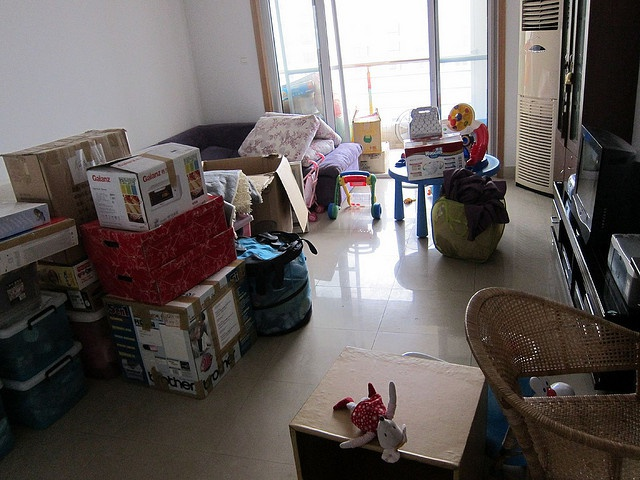Describe the objects in this image and their specific colors. I can see chair in darkgray, black, and gray tones, couch in darkgray, black, and gray tones, tv in darkgray, black, and gray tones, teddy bear in darkgray, black, maroon, and gray tones, and handbag in darkgray and gray tones in this image. 